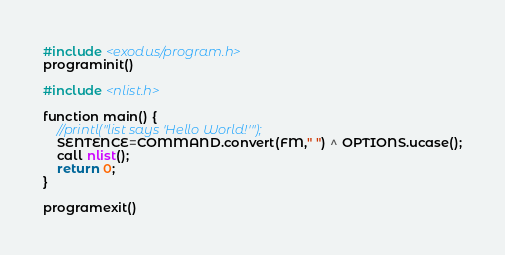Convert code to text. <code><loc_0><loc_0><loc_500><loc_500><_C++_>#include <exodus/program.h>
programinit()

#include <nlist.h>

function main() {
	//printl("list says 'Hello World!'");
	SENTENCE=COMMAND.convert(FM," ") ^ OPTIONS.ucase();
	call nlist();
	return 0;
}

programexit()

</code> 